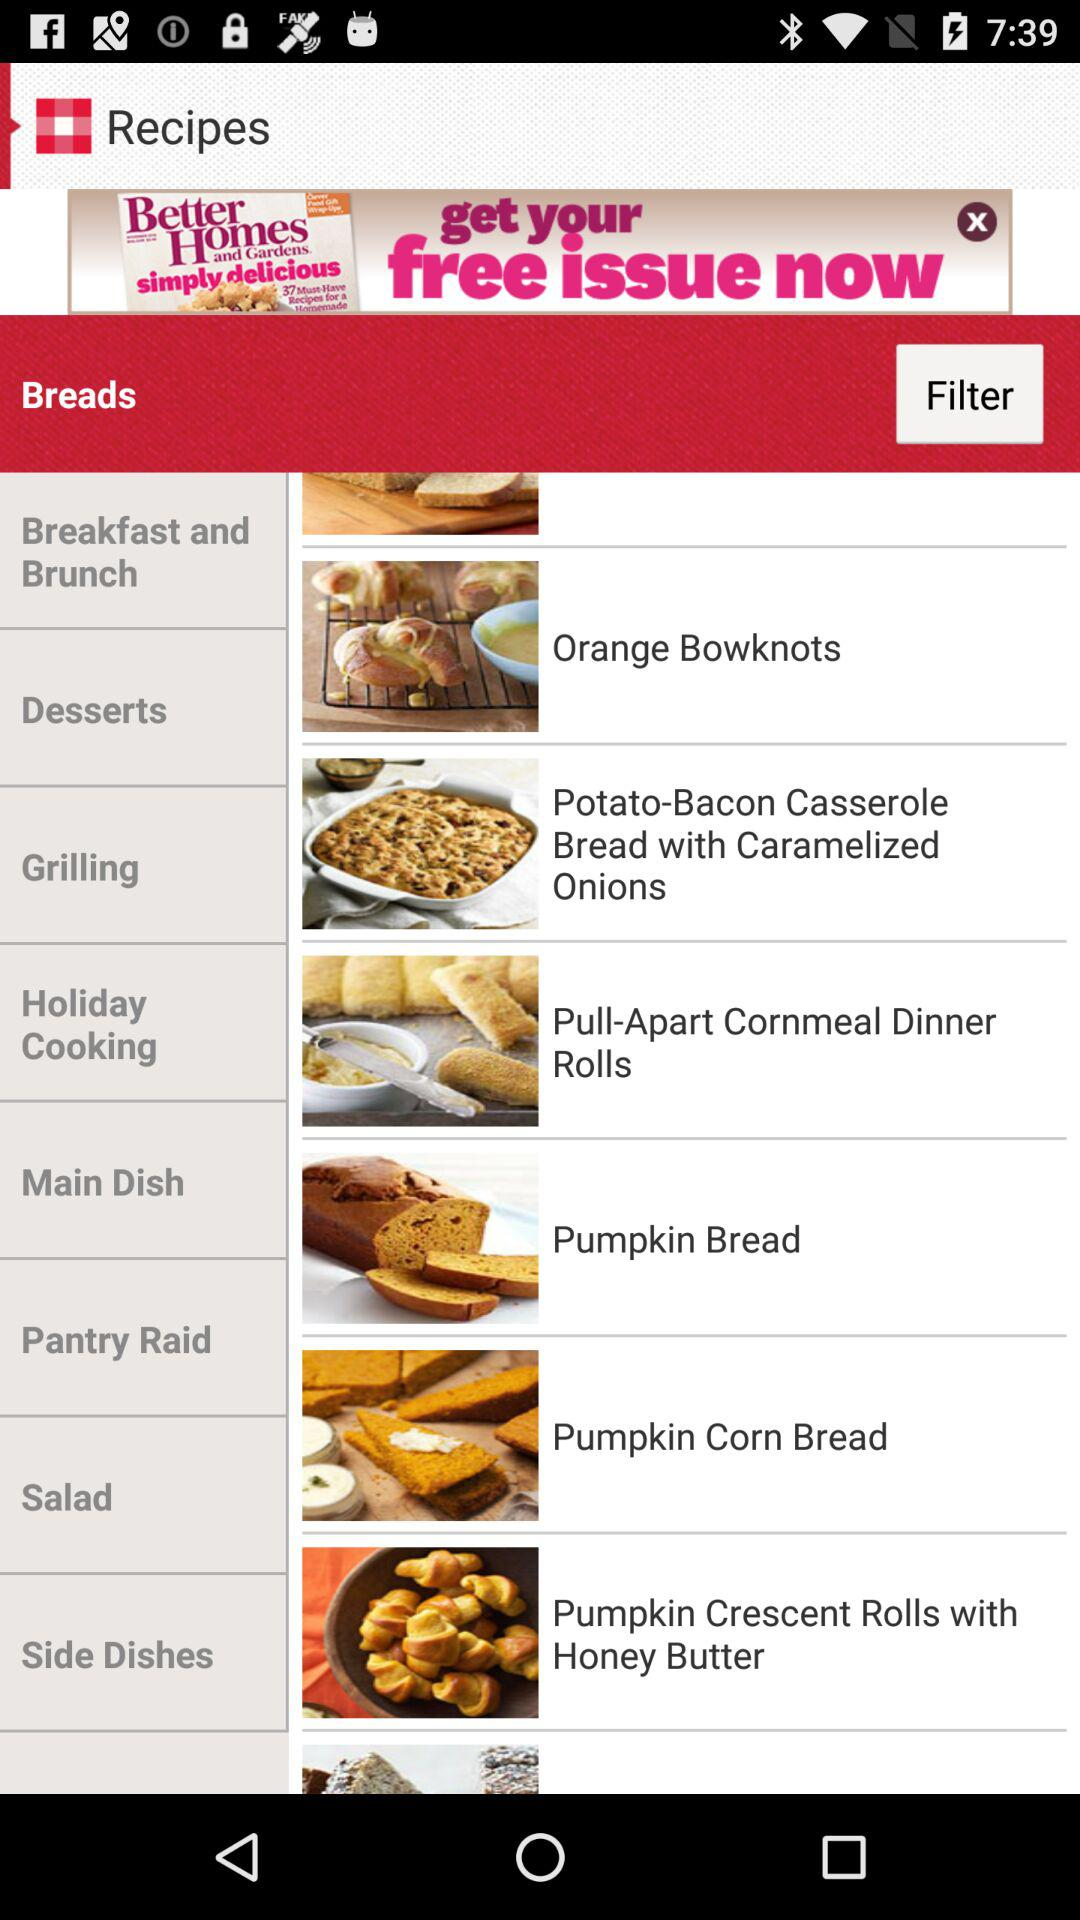What are the different bread options available? The different bread options available are "Pumpkin Bread" and "Pumpkin Corn Bread". 